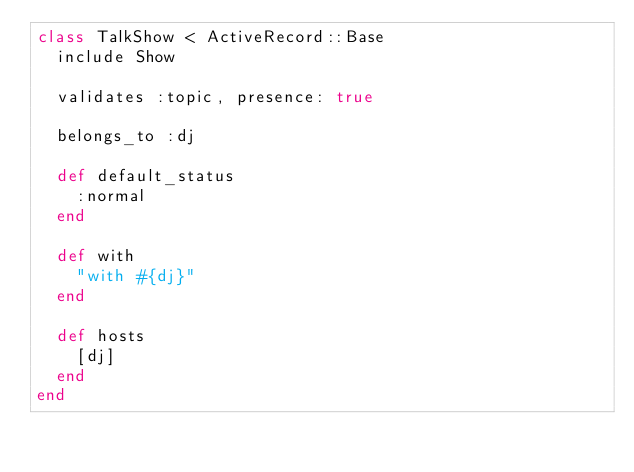<code> <loc_0><loc_0><loc_500><loc_500><_Ruby_>class TalkShow < ActiveRecord::Base
  include Show

  validates :topic, presence: true 

  belongs_to :dj

  def default_status
    :normal
  end

  def with
    "with #{dj}"
  end

  def hosts
    [dj]
  end
end
</code> 